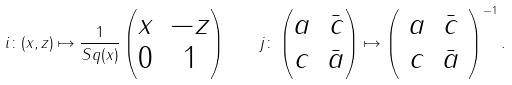<formula> <loc_0><loc_0><loc_500><loc_500>i \colon ( x , z ) \mapsto \frac { 1 } { S q ( x ) } \begin{pmatrix} x & - z \\ 0 & 1 \end{pmatrix} \quad j \colon \begin{pmatrix} a & \bar { c } \\ c & \bar { a } \end{pmatrix} \mapsto \left ( \begin{array} { c c } a & \bar { c } \\ c & \bar { a } \end{array} \right ) ^ { - 1 } .</formula> 